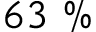<formula> <loc_0><loc_0><loc_500><loc_500>6 3 \ \%</formula> 